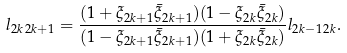Convert formula to latex. <formula><loc_0><loc_0><loc_500><loc_500>l _ { 2 k \, 2 k + 1 } = \frac { ( 1 + \xi _ { 2 k + 1 } \bar { \xi } _ { 2 k + 1 } ) ( 1 - \xi _ { 2 k } \bar { \xi } _ { 2 k } ) } { ( 1 - \xi _ { 2 k + 1 } \bar { \xi } _ { 2 k + 1 } ) ( 1 + \xi _ { 2 k } \bar { \xi } _ { 2 k } ) } l _ { 2 k - 1 \, 2 k } .</formula> 